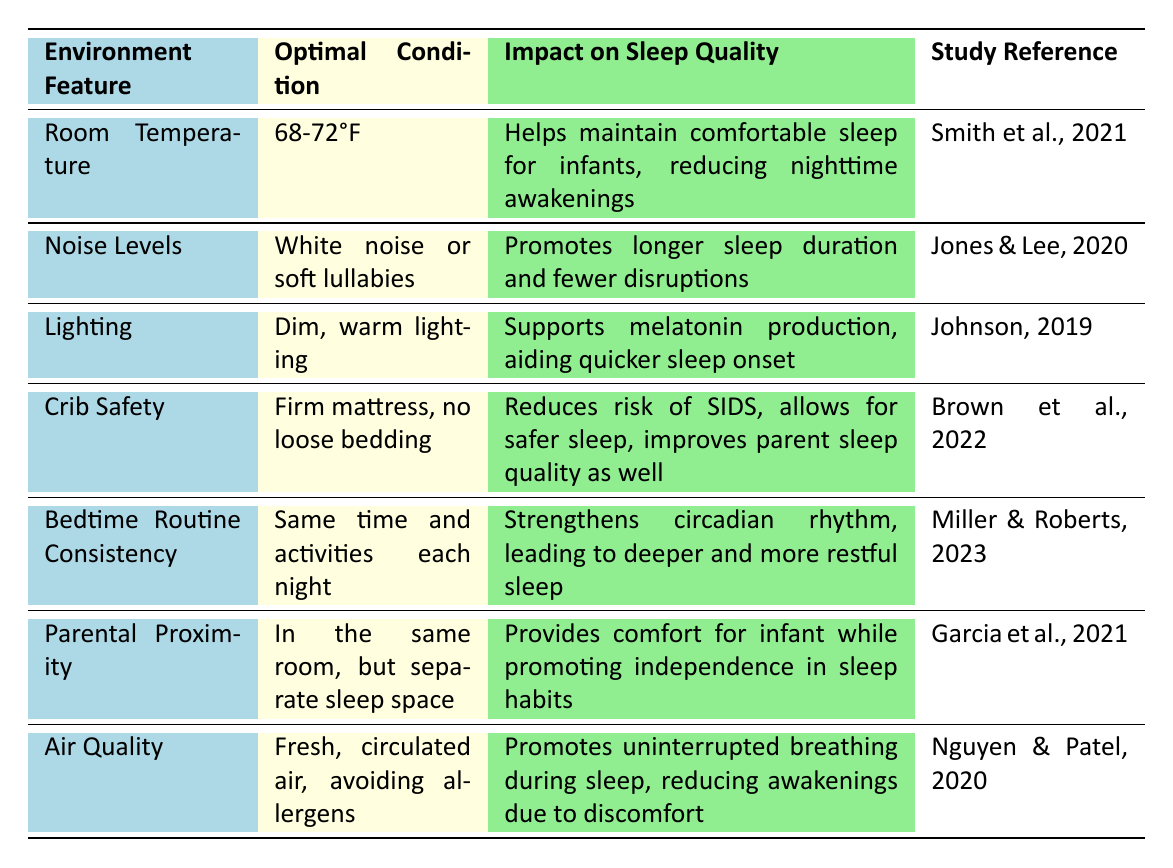What is the optimal room temperature for infant sleep? The table specifies the optimal room temperature as 68-72°F.
Answer: 68-72°F Which environment feature involves the use of white noise or lullabies? The feature related to white noise or soft lullabies is "Noise Levels," according to the table.
Answer: Noise Levels True or False: Dim, warm lighting supports quicker onset of sleep. The table indicates that dim, warm lighting supports melatonin production, aiding quicker sleep onset, which means the statement is true.
Answer: True What are the optimal conditions for crib safety? The optimal conditions for crib safety, as stated in the table, are a firm mattress and no loose bedding.
Answer: Firm mattress, no loose bedding How does consistent bedtime routine impact sleep? The table says that a consistent bedtime routine strengthens circadian rhythm, leading to deeper and more restful sleep.
Answer: Strengthens circadian rhythm What feature supports uninterrupted breathing during sleep? The feature that promotes uninterrupted breathing during sleep is "Air Quality," specified in the table.
Answer: Air Quality If an infant sleeps in a dark room with a firm mattress, which two environment features are being addressed? The dark room relates to "Lighting," while the firm mattress addresses "Crib Safety." Both features are mentioned in the table.
Answer: Lighting, Crib Safety How do optimal noise levels contribute to an infant's sleep quality? The optimal noise levels promote longer sleep duration and fewer disruptions, as described in the table.
Answer: Longer sleep duration What is the relationship between parental proximity and infant sleep habits? Parental proximity in the same room but separate sleep space provides comfort while promoting independence in sleep habits, according to the table.
Answer: Comfort and independence What is the combined focus of the environment features "Air Quality" and "Room Temperature"? Both features focus on creating a comfortable and safe sleep environment, where air quality promotes breathing and room temperature maintains comfort, as per the table.
Answer: Comfortable and safe sleep environment 